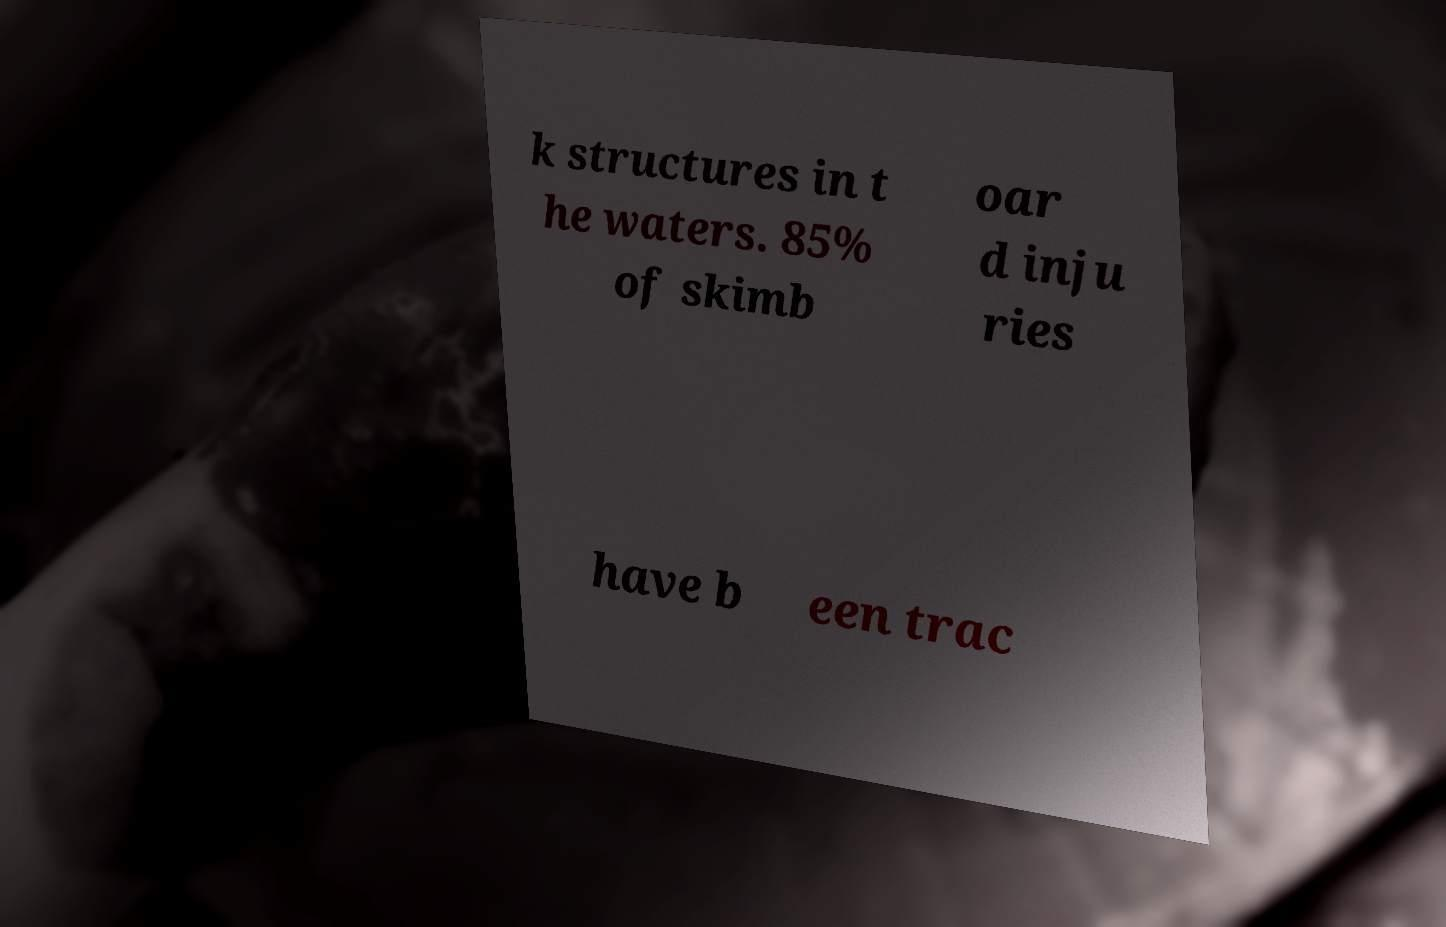For documentation purposes, I need the text within this image transcribed. Could you provide that? k structures in t he waters. 85% of skimb oar d inju ries have b een trac 